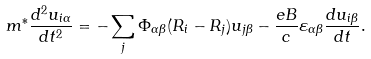Convert formula to latex. <formula><loc_0><loc_0><loc_500><loc_500>m ^ { * } \frac { d ^ { 2 } u _ { i \alpha } } { d t ^ { 2 } } = - \sum _ { j } \Phi _ { \alpha \beta } ( { R } _ { i } - { R } _ { j } ) u _ { j \beta } - \frac { e B } { c } \varepsilon _ { \alpha \beta } \frac { d u _ { i \beta } } { d t } .</formula> 